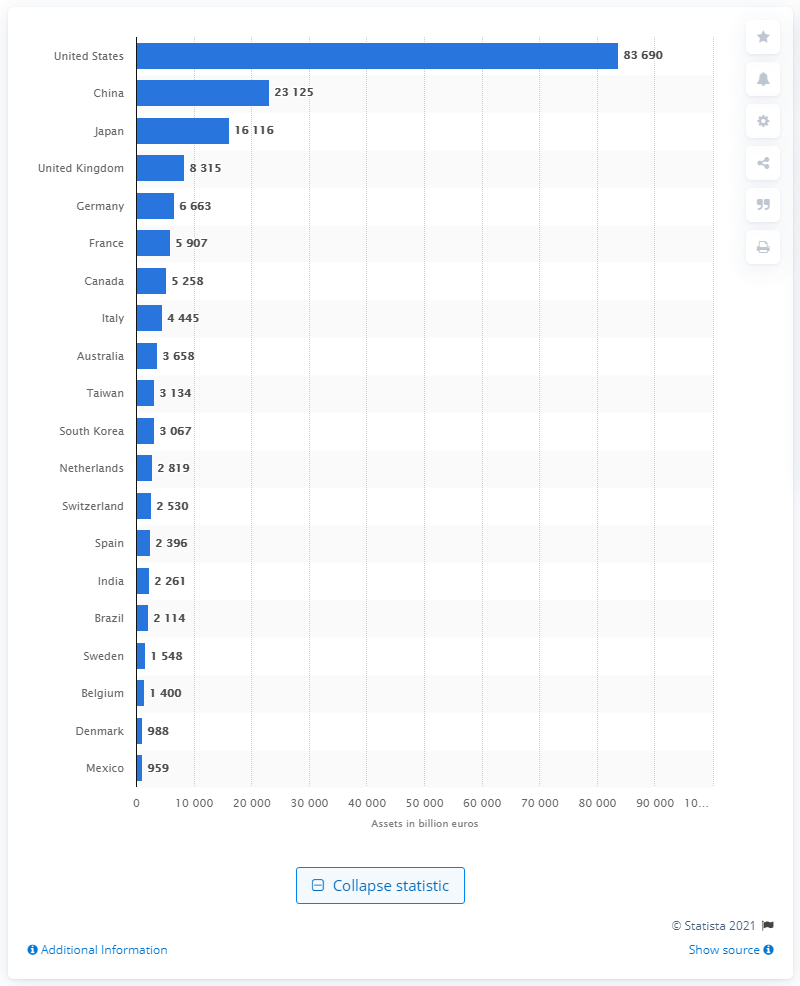Highlight a few significant elements in this photo. In 2019, the gross financial assets of U.S. households were approximately 83,690 billion dollars. 